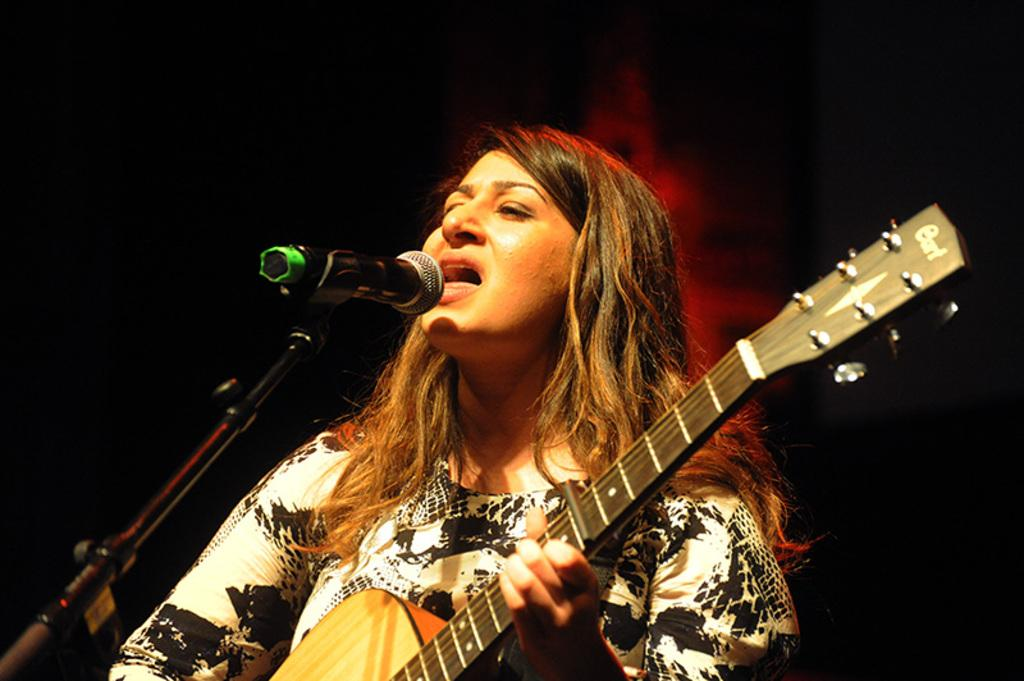Who is the main subject in the image? There is a woman in the image. What is the woman wearing? The woman is wearing a white and black dress. What is the woman doing in the image? The woman is playing a guitar and singing. What object is the woman standing in front of? She is standing in front of a microphone. What type of orange is the woman holding in the image? There is no orange present in the image; the woman is playing a guitar and singing. Can you describe the acoustics of the room in the image? The provided facts do not give any information about the acoustics of the room in the image. 